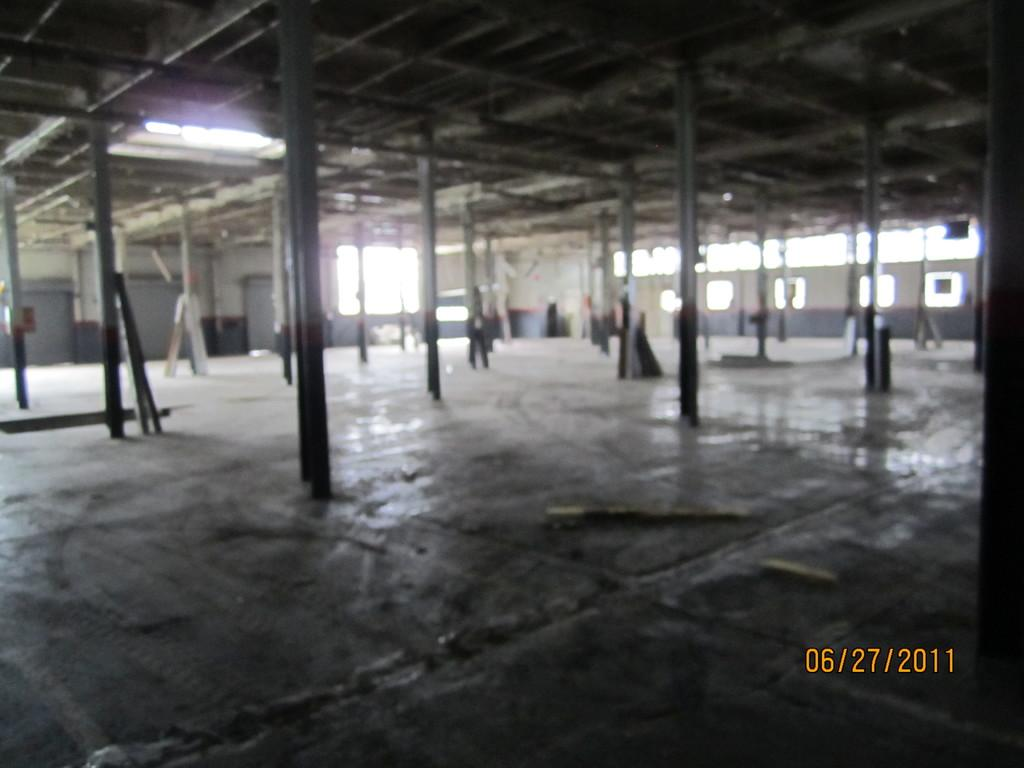What type of structure is depicted in the image? There is a hall in the image. What material is used for the pillars in the hall? The hall has wooden pillars. What is the roof of the hall made of? The hall has a wooden roof. Where is the watermark located in the image? The watermark is in the right bottom of the image. What historical event is being commemorated in the image? There is no indication of a historical event being commemorated in the image; it simply depicts a hall with wooden pillars and a wooden roof. What type of furniture can be seen in the image? There is no furniture visible in the image; it only shows the hall with its architectural features. 